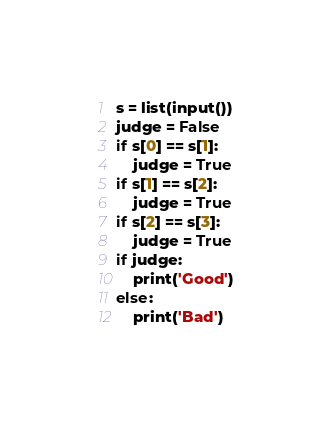<code> <loc_0><loc_0><loc_500><loc_500><_Python_>s = list(input())
judge = False
if s[0] == s[1]:
    judge = True
if s[1] == s[2]:
    judge = True
if s[2] == s[3]:
    judge = True
if judge:
    print('Good')
else:
    print('Bad')</code> 